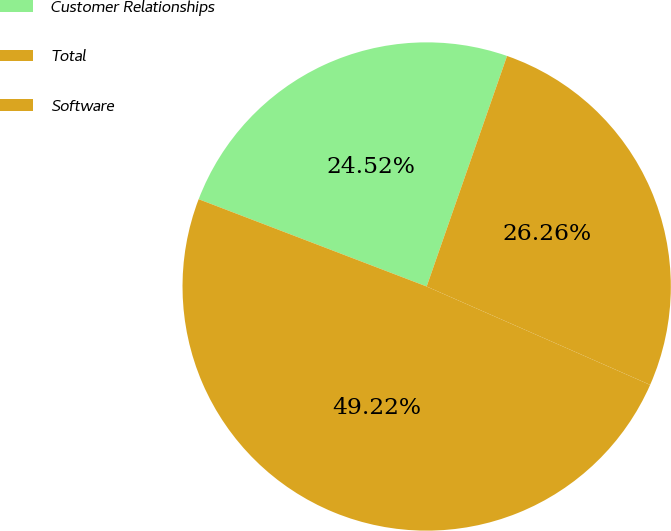<chart> <loc_0><loc_0><loc_500><loc_500><pie_chart><fcel>Customer Relationships<fcel>Total<fcel>Software<nl><fcel>24.52%<fcel>26.26%<fcel>49.22%<nl></chart> 